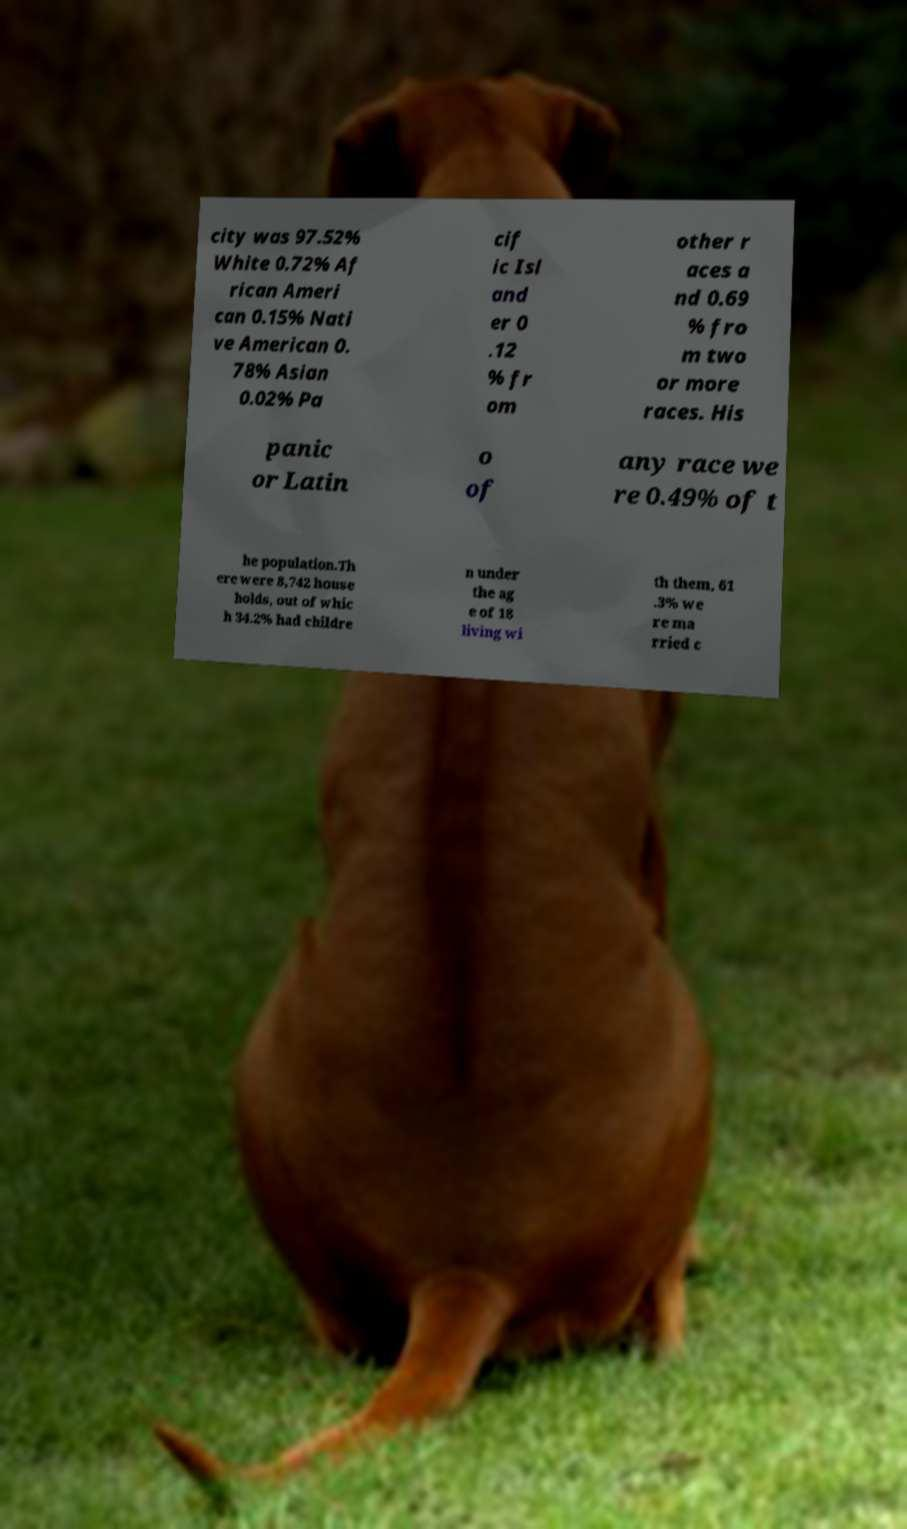Please identify and transcribe the text found in this image. city was 97.52% White 0.72% Af rican Ameri can 0.15% Nati ve American 0. 78% Asian 0.02% Pa cif ic Isl and er 0 .12 % fr om other r aces a nd 0.69 % fro m two or more races. His panic or Latin o of any race we re 0.49% of t he population.Th ere were 8,742 house holds, out of whic h 34.2% had childre n under the ag e of 18 living wi th them, 61 .3% we re ma rried c 